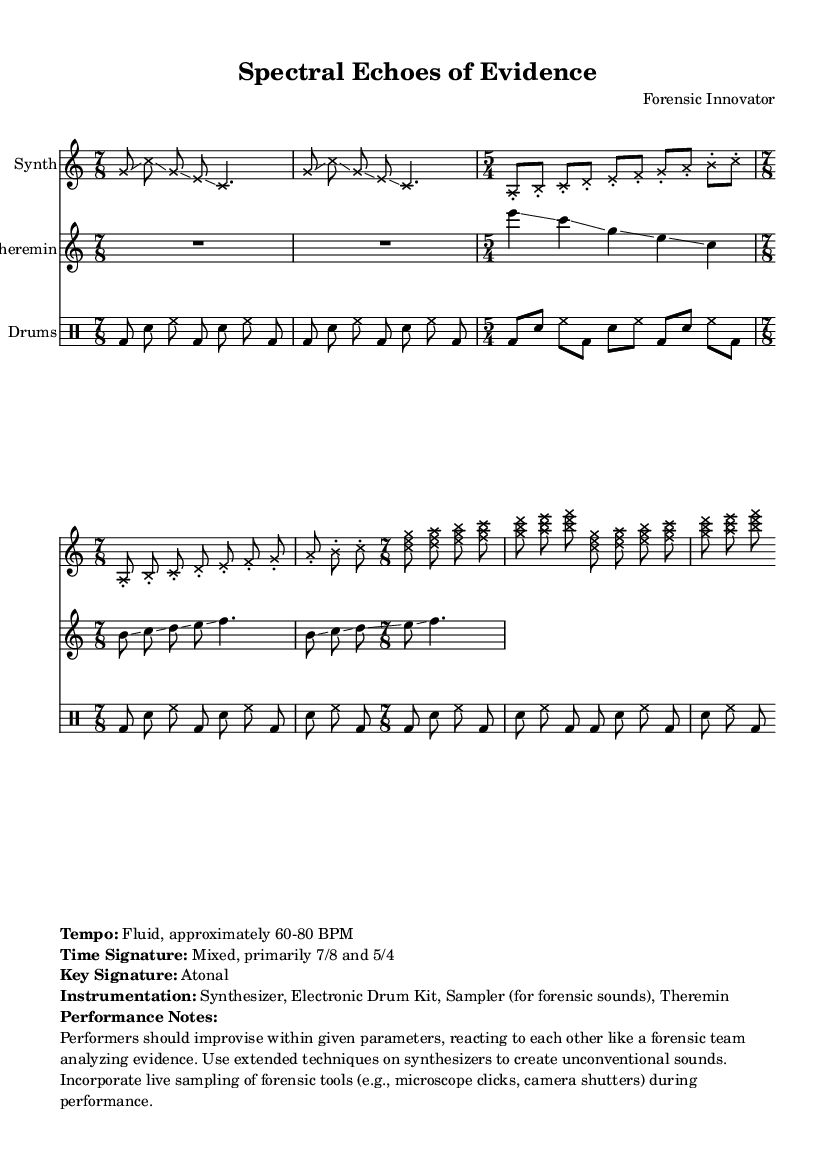What is the primary time signature used in this composition? The music primarily features two time signatures, 5/4 and 7/8, as stated in the markup specifications. The first set of repeated measures is predominantly in 7/8.
Answer: 7/8 What tempo should the performers aim for? The tempo indicated in the markup is fluid, approximately between 60 and 80 BPM, which suggests a range rather than a strict tempo.
Answer: Fluid, approximately 60-80 BPM What instruments are used in this composition? The markup clearly lists the utilized instruments: Synthesizer, Electronic Drum Kit, Sampler (for forensic sounds), and Theremin.
Answer: Synthesizer, Electronic Drum Kit, Sampler, Theremin How many repeated sections are there in the drum patterns? By analyzing the drum pattern section, it is evident that each pattern is repeated twice, making it a total of four occurrences in the specified time signatures.
Answer: 4 What is the key signature of this composition? Atonality is explicitly stated in the markup, indicating there is no specific key signature governing the piece. This absence confirms its modern experimental style.
Answer: Atonal Which extended techniques are suggested for the synthesizers? The performance notes suggest improvisation and the use of unconventional sounds, emphasizing the creative interaction akin to forensic analysis. This implies flexibility in exploring sound production.
Answer: Extended techniques What does the term "glissando" mean as used in this composition? The term "glissando" indicates a smooth slide between pitches, as seen in both synthesizer and theremin parts, suggesting fluid transitions between notes, which aligns with the experimental style.
Answer: Smooth slide between pitches 